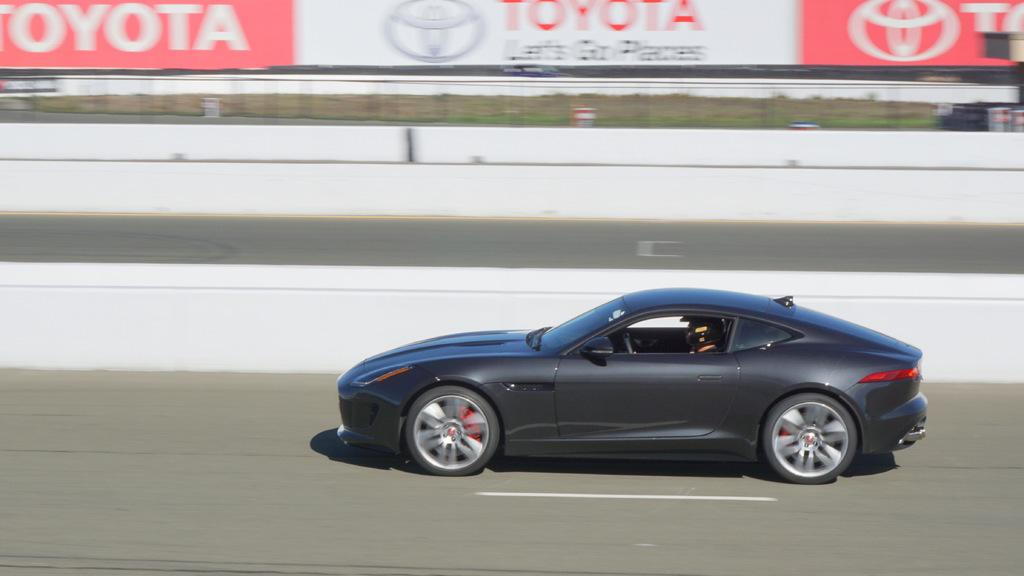What is the main subject of the image? The main subject of the image is a person driving a car. Where is the car located in the image? The car is on the road in the image. What can be seen in the background of the image? There is a banner with text in the background of the image. Can you tell me how deep the lake is in the image? There is no lake present in the image; it features a person driving a car on the road. What type of respect is being shown in the image? There is no indication of respect being shown in the image, as it focuses on a person driving a car on the road. 